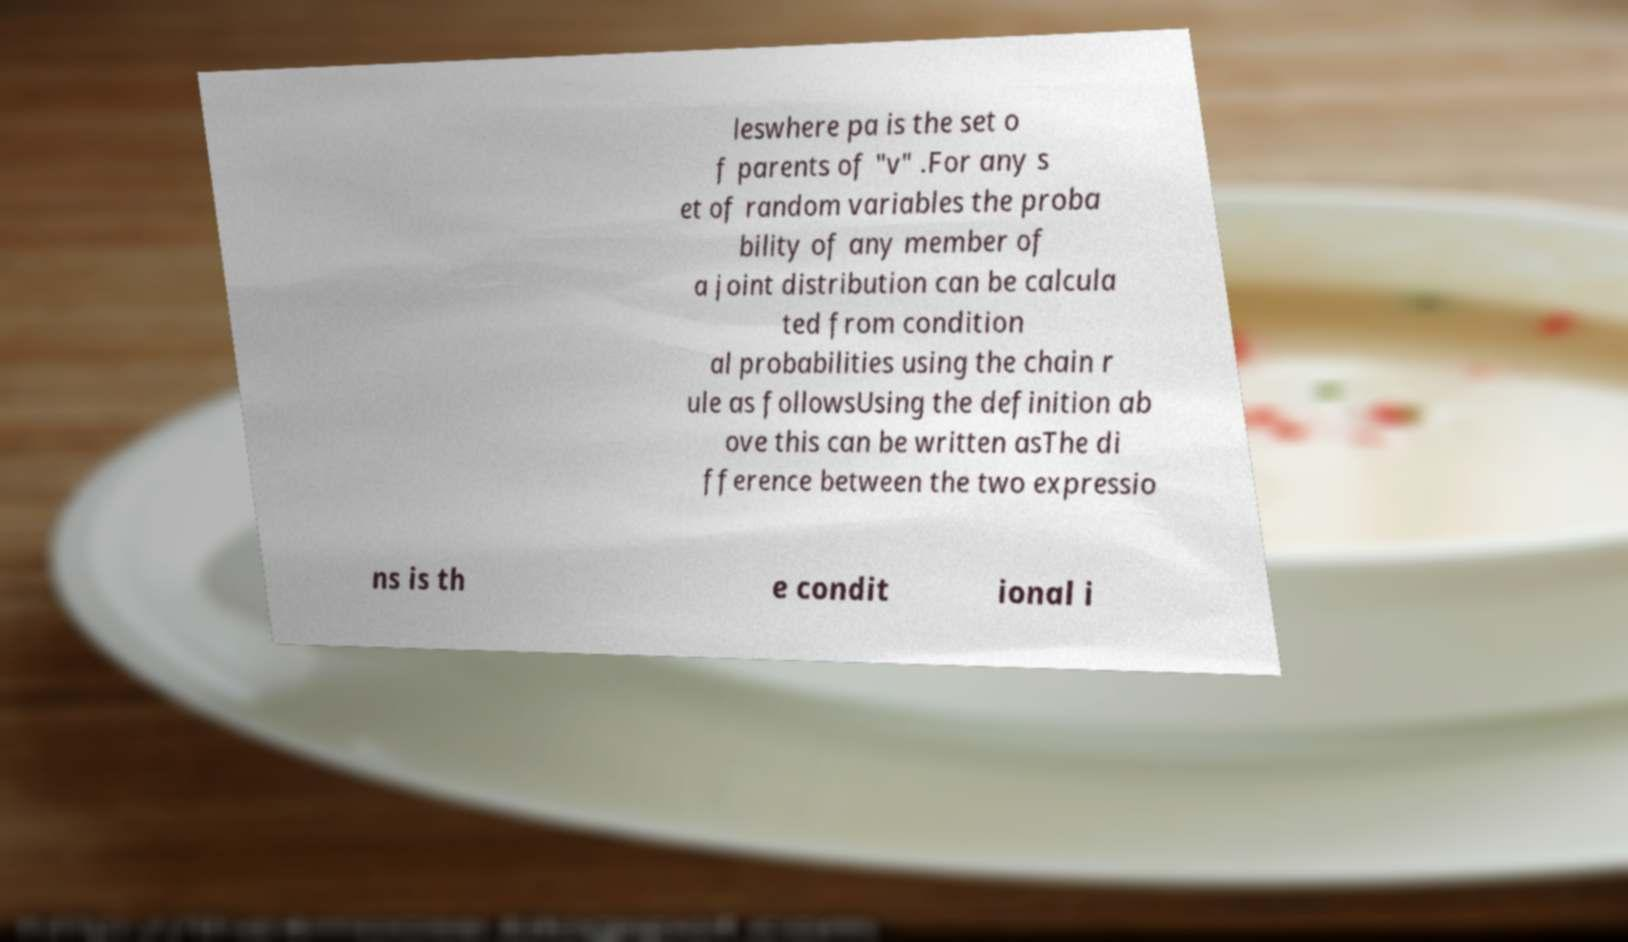Please read and relay the text visible in this image. What does it say? leswhere pa is the set o f parents of "v" .For any s et of random variables the proba bility of any member of a joint distribution can be calcula ted from condition al probabilities using the chain r ule as followsUsing the definition ab ove this can be written asThe di fference between the two expressio ns is th e condit ional i 